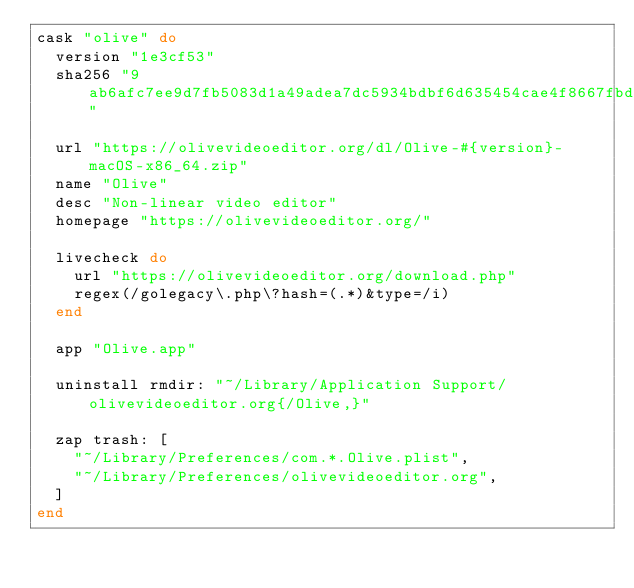Convert code to text. <code><loc_0><loc_0><loc_500><loc_500><_Ruby_>cask "olive" do
  version "1e3cf53"
  sha256 "9ab6afc7ee9d7fb5083d1a49adea7dc5934bdbf6d635454cae4f8667fbd7c368"

  url "https://olivevideoeditor.org/dl/Olive-#{version}-macOS-x86_64.zip"
  name "Olive"
  desc "Non-linear video editor"
  homepage "https://olivevideoeditor.org/"

  livecheck do
    url "https://olivevideoeditor.org/download.php"
    regex(/golegacy\.php\?hash=(.*)&type=/i)
  end

  app "Olive.app"

  uninstall rmdir: "~/Library/Application Support/olivevideoeditor.org{/Olive,}"

  zap trash: [
    "~/Library/Preferences/com.*.Olive.plist",
    "~/Library/Preferences/olivevideoeditor.org",
  ]
end
</code> 